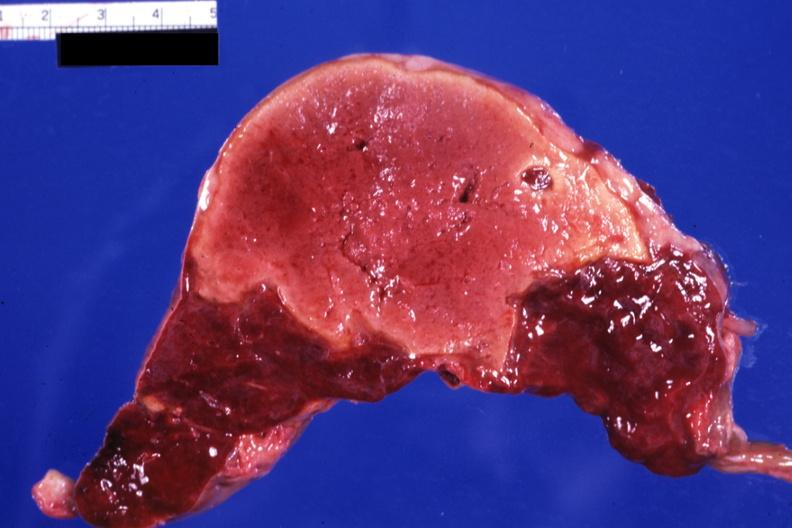does normal immature infant show large yellow lesion probably several weeks of age?
Answer the question using a single word or phrase. No 